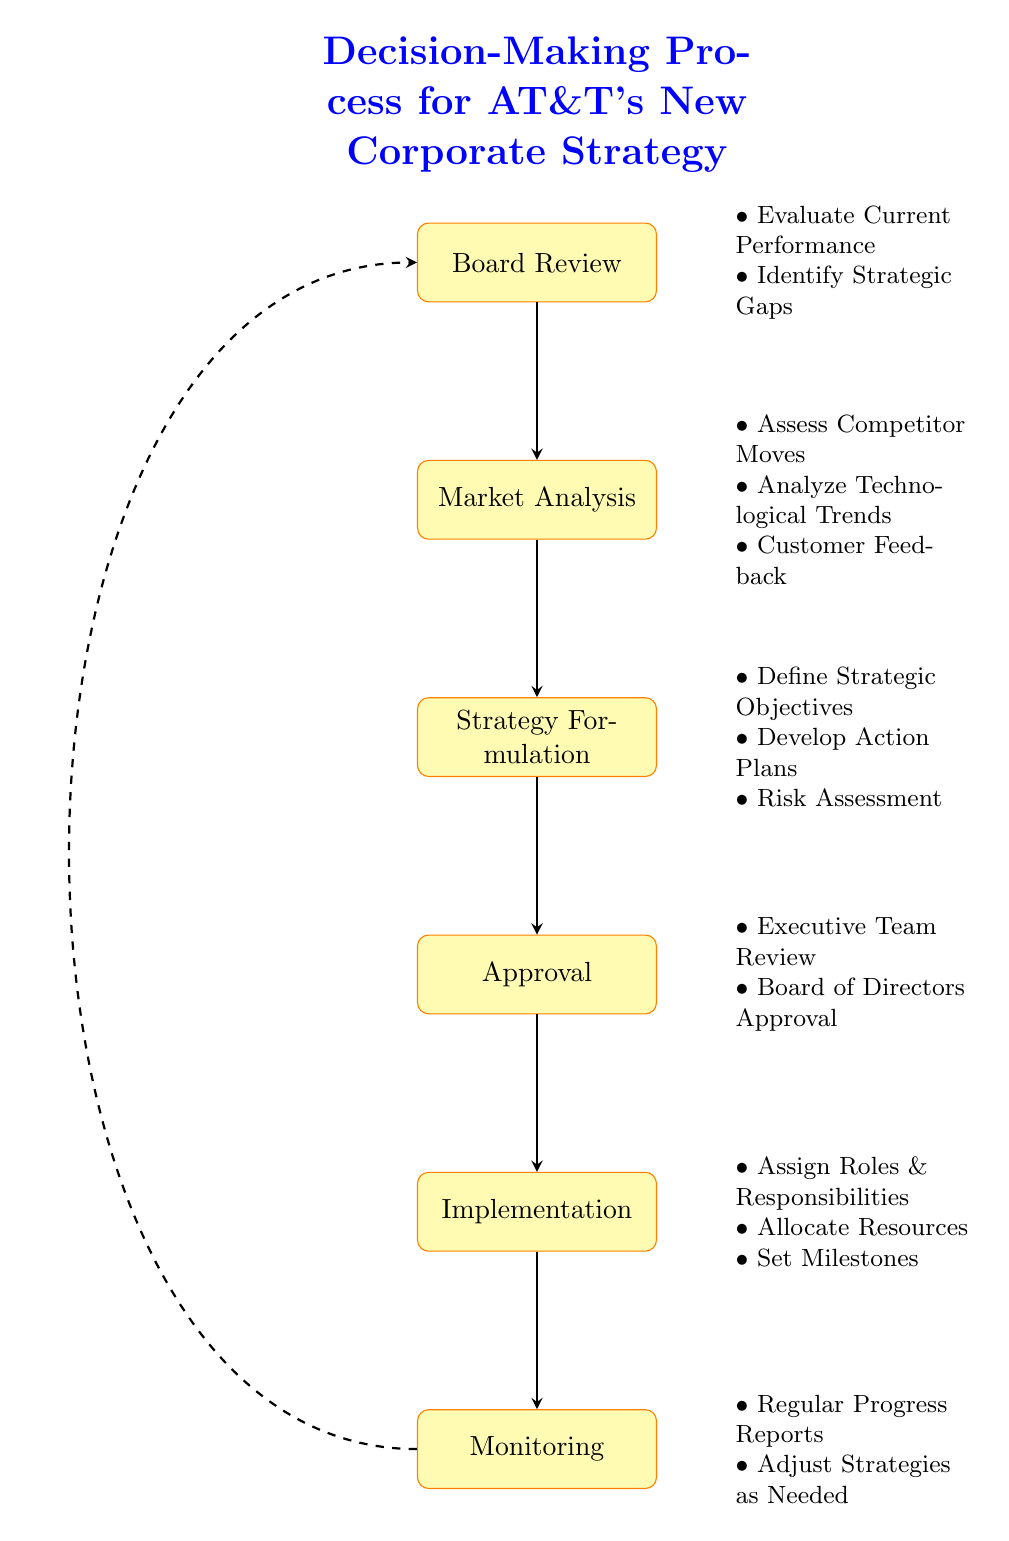What is the first step in the decision-making process? The first step identified in the flow chart is "Board Review." It is the topmost node from which the process begins.
Answer: Board Review How many nodes are in the diagram? Counting all the distinct nodes listed, we find there are six: "Board Review," "Market Analysis," "Strategy Formulation," "Approval," "Implementation," and "Monitoring."
Answer: 6 What is the last step of the decision-making process? The final step in the diagram is "Monitoring," which is the bottom node indicating the conclusion of the flow process.
Answer: Monitoring Which phase follows "Strategy Formulation"? Looking at the flow of the diagram, "Approval" immediately follows "Strategy Formulation" as the next step in the sequence.
Answer: Approval How many actions are listed under "Market Analysis"? The "Market Analysis" node has three actions associated with it, which are detailed on the right side of the diagram.
Answer: 3 What is assessed during "Market Analysis"? The specified actions during "Market Analysis" include "Assess Competitor Moves," "Analyze Technological Trends," and "Customer Feedback," showing what is assessed in this phase.
Answer: Assess Competitor Moves, Analyze Technological Trends, Customer Feedback What happens after "Implementation"? According to the flow chart, "Monitoring" is the immediate next step after the "Implementation" phase, indicating a sequence of actions.
Answer: Monitoring What is the purpose of "Risk Assessment"? "Risk Assessment," which is part of "Strategy Formulation," serves to identify potential risks related to the strategic initiatives being proposed.
Answer: Identify potential risks Which two approvals are necessary before moving to "Implementation"? The approvals required prior to "Implementation" are "Executive Team Review" and "Board of Directors Approval," which are listed under the "Approval" node.
Answer: Executive Team Review, Board of Directors Approval What feedback is considered during "Market Analysis"? The flow chart indicates that "Customer Feedback" is one of the key elements considered during the "Market Analysis" phase.
Answer: Customer Feedback 